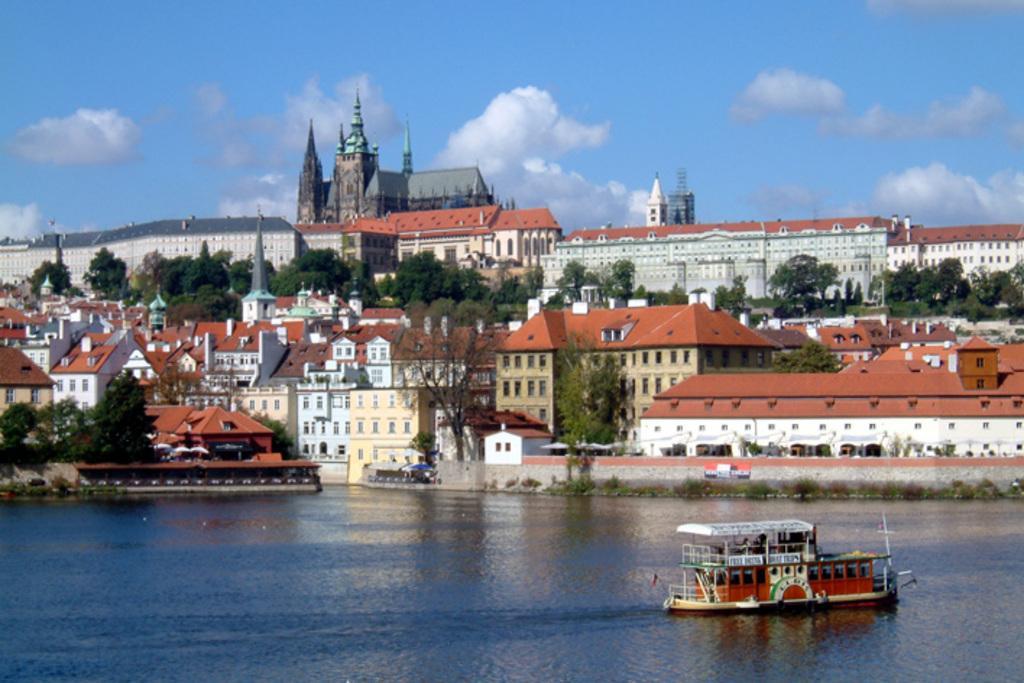Please provide a concise description of this image. In this picture we can see a boat on water and in the background we can see buildings,trees,sky. 